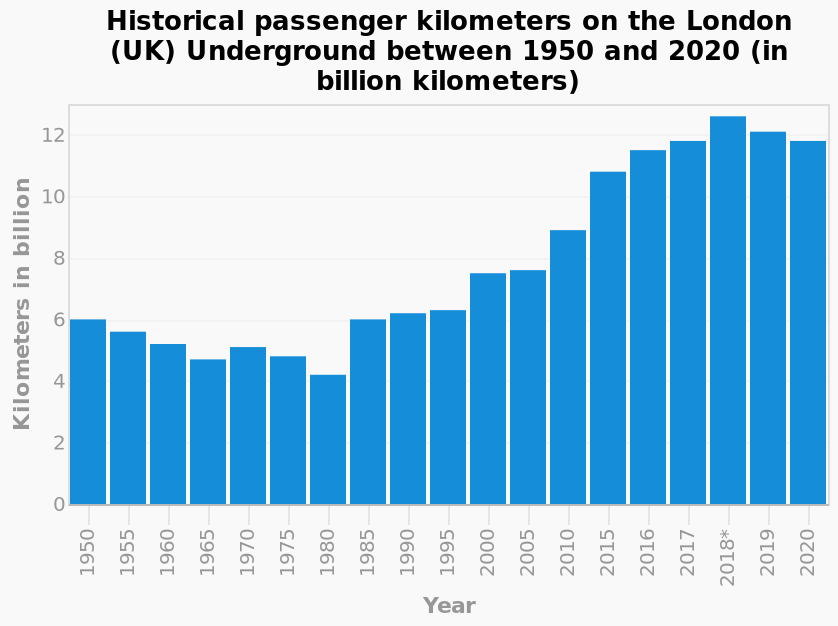<image>
What is the title of the bar chart?  The title of the bar chart is "Historical passenger kilometers on the London (UK) Underground between 1950 and 2020 (in billion kilometers)." What is the minimum value shown on the y-axis of the bar chart? The minimum value shown on the y-axis of the bar chart is 0 billion kilometers. 